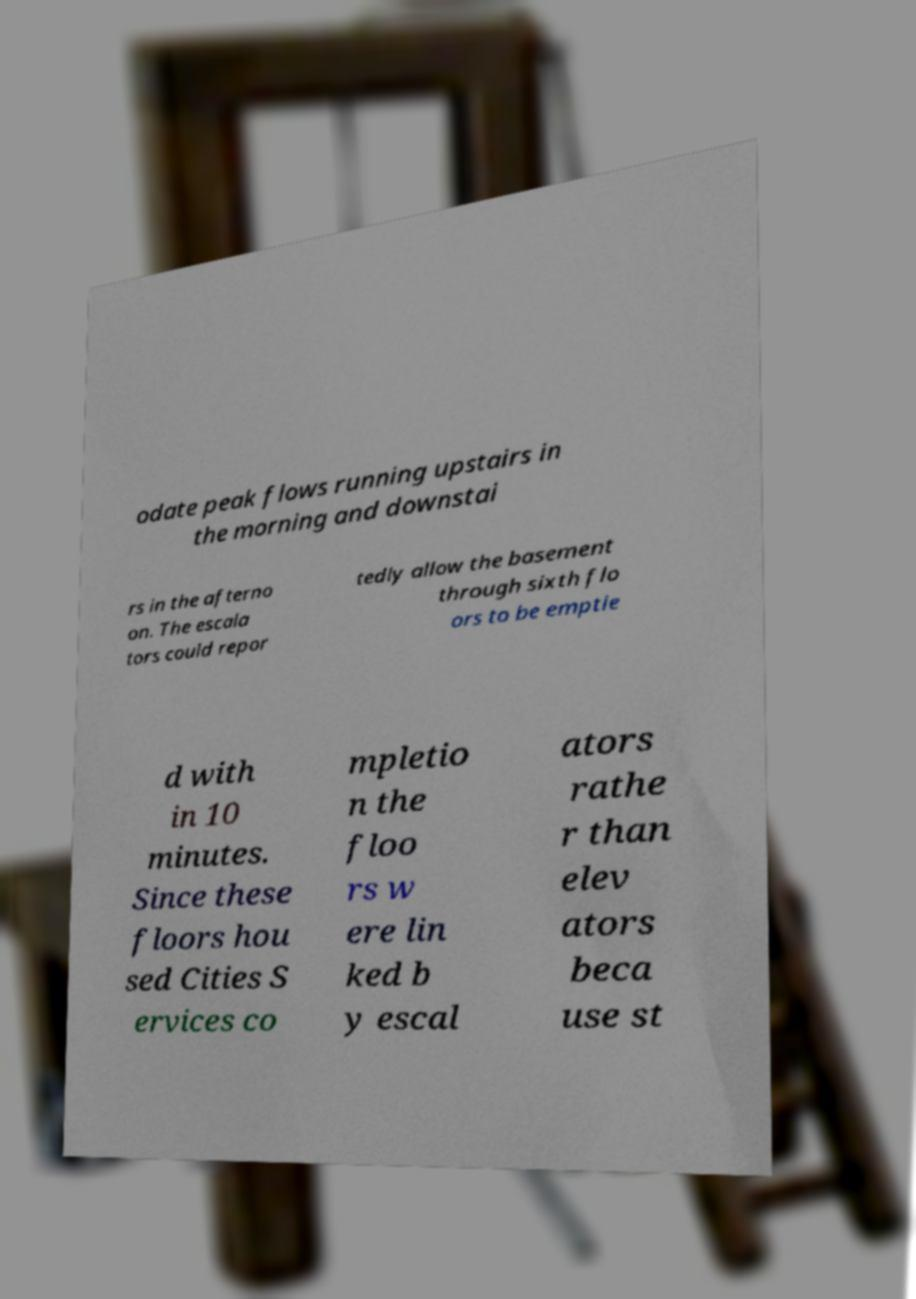Can you read and provide the text displayed in the image?This photo seems to have some interesting text. Can you extract and type it out for me? odate peak flows running upstairs in the morning and downstai rs in the afterno on. The escala tors could repor tedly allow the basement through sixth flo ors to be emptie d with in 10 minutes. Since these floors hou sed Cities S ervices co mpletio n the floo rs w ere lin ked b y escal ators rathe r than elev ators beca use st 